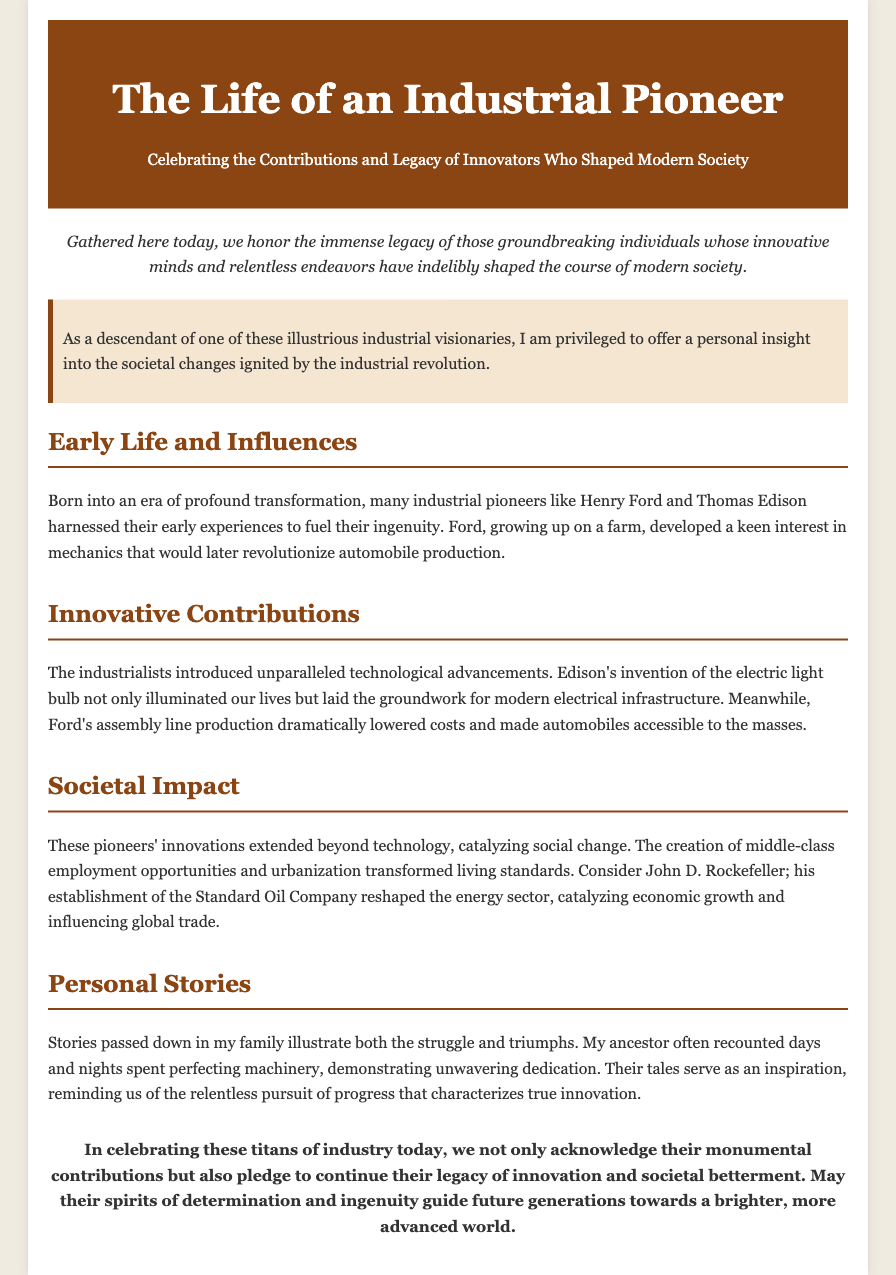what is the title of the document? The title is mentioned in the header section of the document.
Answer: The Life of an Industrial Pioneer who are mentioned as industrial pioneers in the document? The document references specific individuals known for their contributions, such as Henry Ford and Thomas Edison.
Answer: Henry Ford and Thomas Edison what technological advancement did Edison invent? The document specifically states the invention made by Edison, which is detailed in the section on innovative contributions.
Answer: Electric light bulb what impact did Ford's assembly line production have? The document discusses the effect of Ford's innovation on automobile production costs and accessibility.
Answer: Dramatically lowered costs which company did John D. Rockefeller establish? The document explicitly names the company that played a significant role in the energy sector.
Answer: Standard Oil Company what motivates the personal stories shared in the document? The personal stories included in the document reflect certain qualities related to industrial pioneers' experiences, as discussed in the section about personal stories.
Answer: Unwavering dedication what does the conclusion of the eulogy emphasize? The final thoughts of the document stress the importance of continuing a certain legacy, as outlined in the conclusion section.
Answer: Legacy of innovation how does the introduction frame the purpose of the gathering? The introduction provides insight into the collective aim of the gathering as mentioned at the beginning of the document.
Answer: Honor the immense legacy 